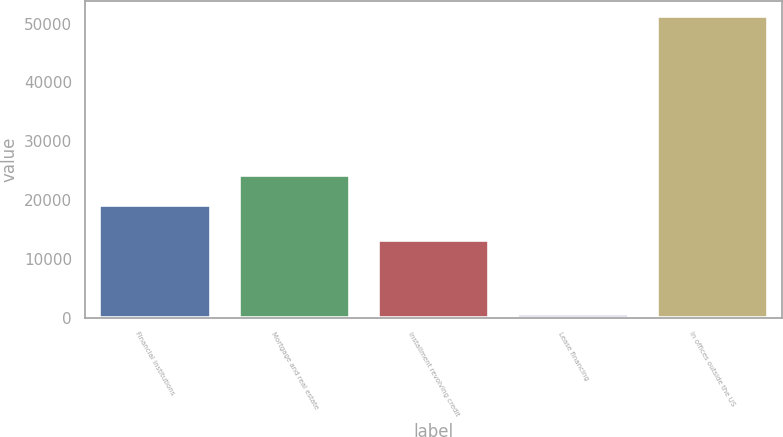Convert chart. <chart><loc_0><loc_0><loc_500><loc_500><bar_chart><fcel>Financial institutions<fcel>Mortgage and real estate<fcel>Installment revolving credit<fcel>Lease financing<fcel>In offices outside the US<nl><fcel>19169<fcel>24240.4<fcel>13155<fcel>566<fcel>51280<nl></chart> 